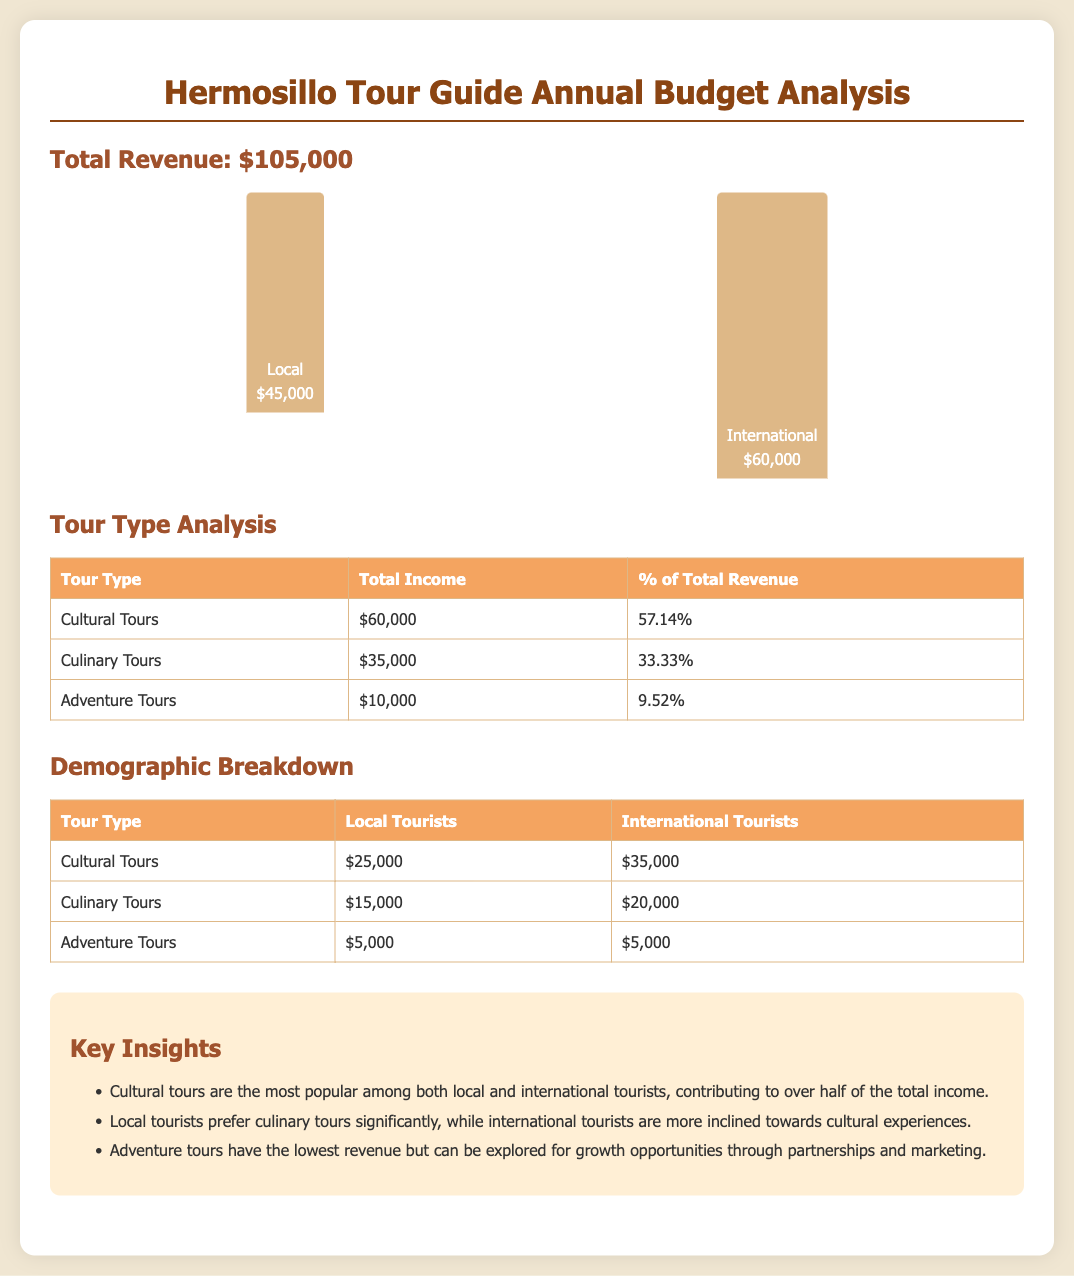what is the total revenue? The total revenue is stated clearly as $105,000 in the document.
Answer: $105,000 how much income did cultural tours generate? The document specifies that cultural tours earned $60,000.
Answer: $60,000 which type of tour has the lowest revenue? The information presented shows that adventure tours generated the least income at $10,000.
Answer: Adventure Tours what percentage of total revenue does culinary tours represent? Culinary tours account for 33.33% of total revenue according to the analysis.
Answer: 33.33% how much did local tourists spend on culinary tours? The document states that local tourists contributed $15,000 to culinary tours.
Answer: $15,000 how much more did international tourists spend on cultural tours compared to local tourists? By comparing the amounts, international tourists spent $10,000 more than local tourists ($35,000 vs. $25,000).
Answer: $10,000 what is the total income from adventure tours for local tourists? The document reveals that local tourists spent $5,000 on adventure tours.
Answer: $5,000 which demographic spent the most on cultural tours? The analysis indicates that international tourists spent more, totaling $35,000 compared to local tourists’ $25,000.
Answer: International Tourists 